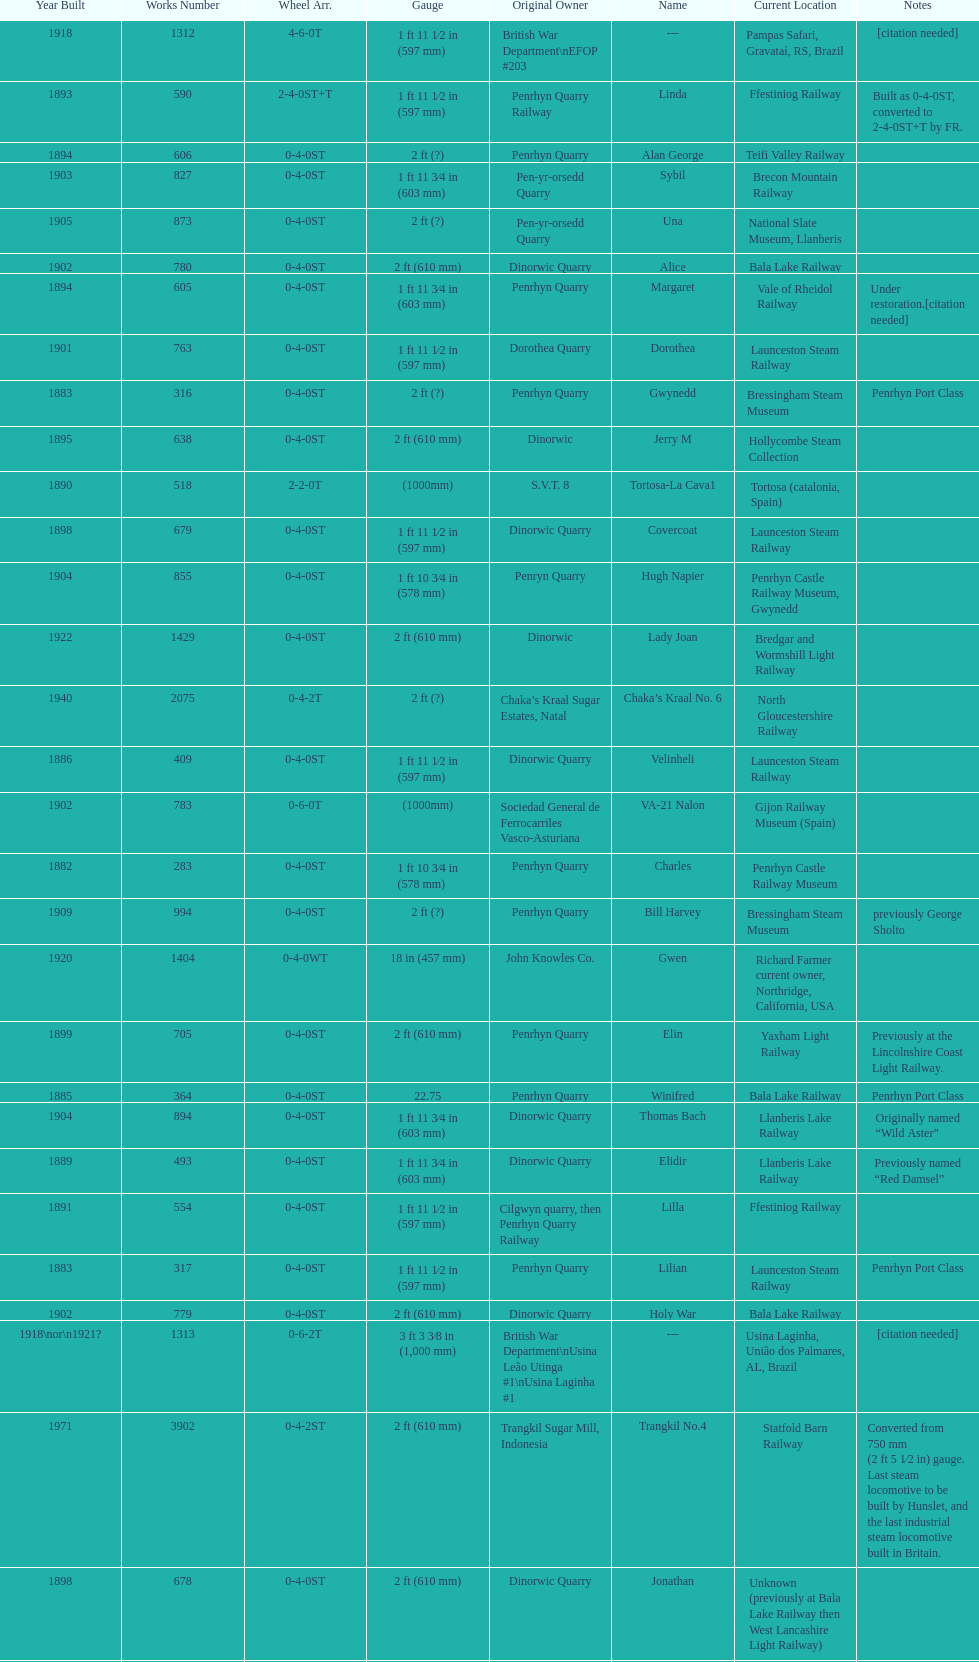At the bala lake railway, how many steam locomotives can be found presently? 364. 